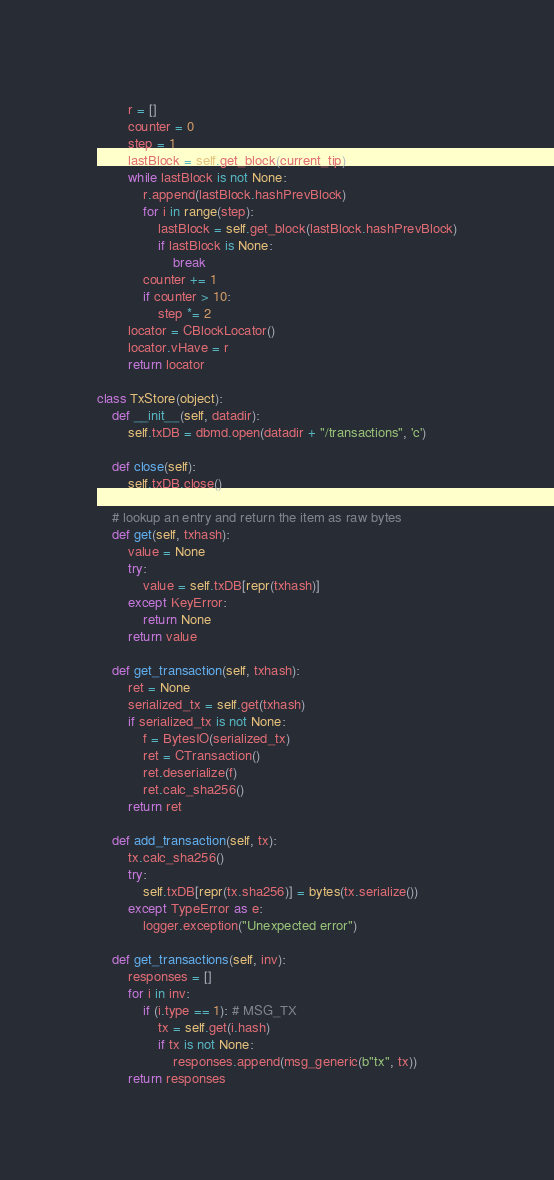<code> <loc_0><loc_0><loc_500><loc_500><_Python_>        r = []
        counter = 0
        step = 1
        lastBlock = self.get_block(current_tip)
        while lastBlock is not None:
            r.append(lastBlock.hashPrevBlock)
            for i in range(step):
                lastBlock = self.get_block(lastBlock.hashPrevBlock)
                if lastBlock is None:
                    break
            counter += 1
            if counter > 10:
                step *= 2
        locator = CBlockLocator()
        locator.vHave = r
        return locator

class TxStore(object):
    def __init__(self, datadir):
        self.txDB = dbmd.open(datadir + "/transactions", 'c')

    def close(self):
        self.txDB.close()

    # lookup an entry and return the item as raw bytes
    def get(self, txhash):
        value = None
        try:
            value = self.txDB[repr(txhash)]
        except KeyError:
            return None
        return value

    def get_transaction(self, txhash):
        ret = None
        serialized_tx = self.get(txhash)
        if serialized_tx is not None:
            f = BytesIO(serialized_tx)
            ret = CTransaction()
            ret.deserialize(f)
            ret.calc_sha256()
        return ret

    def add_transaction(self, tx):
        tx.calc_sha256()
        try:
            self.txDB[repr(tx.sha256)] = bytes(tx.serialize())
        except TypeError as e:
            logger.exception("Unexpected error")

    def get_transactions(self, inv):
        responses = []
        for i in inv:
            if (i.type == 1): # MSG_TX
                tx = self.get(i.hash)
                if tx is not None:
                    responses.append(msg_generic(b"tx", tx))
        return responses
</code> 